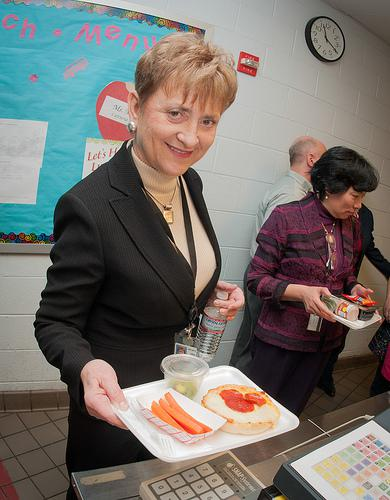Question: when is this taking place?
Choices:
A. Noon.
B. Meal time.
C. Night.
D. Morning.
Answer with the letter. Answer: B Question: how is the person holding the tray?
Choices:
A. Standing.
B. With his leg.
C. Telepathically.
D. With a hand.
Answer with the letter. Answer: D Question: who is holding the tray?
Choices:
A. A woman.
B. A man.
C. A boy.
D. A girl.
Answer with the letter. Answer: A Question: what color is the hair of the woman in front holding the tray?
Choices:
A. Blonde.
B. Brown.
C. Black.
D. Red.
Answer with the letter. Answer: A Question: what is in the paper dish?
Choices:
A. Broccoli.
B. Lettuce.
C. Carrots.
D. Onions.
Answer with the letter. Answer: C Question: what color hair does the woman in back have?
Choices:
A. Brown.
B. Red.
C. Blue.
D. Black.
Answer with the letter. Answer: D 